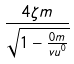<formula> <loc_0><loc_0><loc_500><loc_500>\frac { 4 \zeta m } { \sqrt { 1 - \frac { 0 m } { v u ^ { 0 } } } }</formula> 